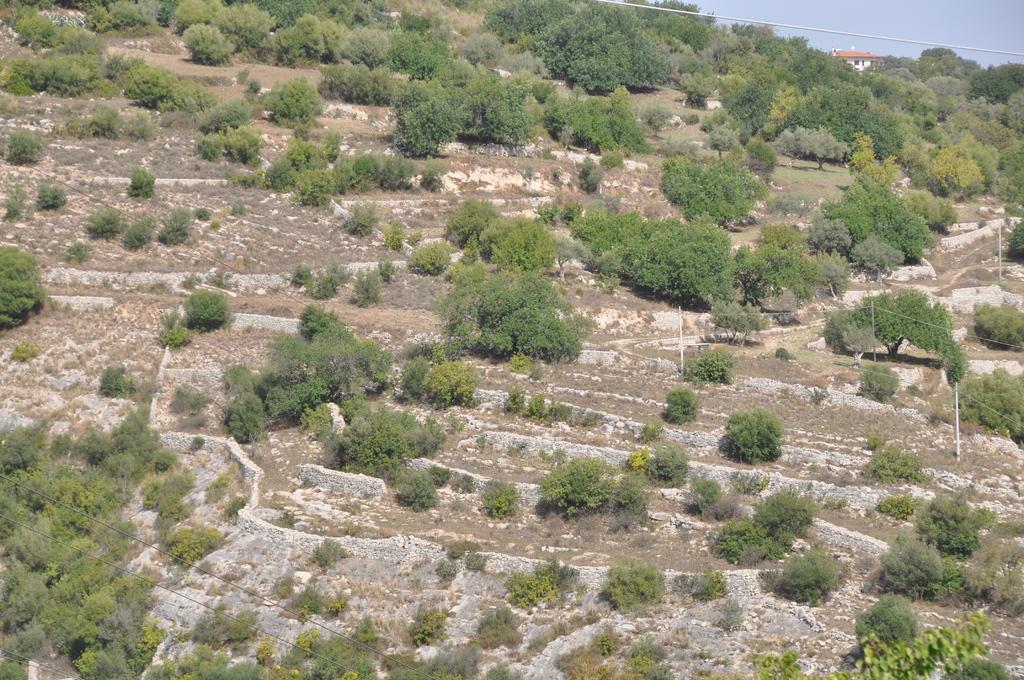Please provide a concise description of this image. In the image we can see there are trees on the ground and behind there is a building. There is a clear sky. 